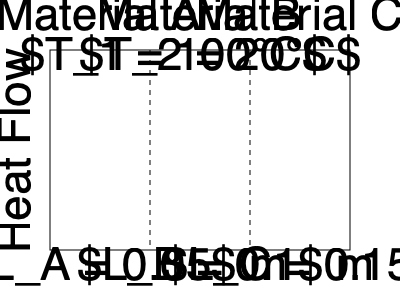A composite wall consists of three layers of materials A, B, and C with thermal conductivities $k_A = 0.8$ W/(m·K), $k_B = 0.5$ W/(m·K), and $k_C = 0.3$ W/(m·K), respectively. The thicknesses of the layers are $L_A = 0.05$ m, $L_B = 0.1$ m, and $L_C = 0.15$ m. If the temperature on the left side is $T_1 = 100°C$ and on the right side is $T_2 = 20°C$, calculate the heat flux through the wall in W/m². To solve this problem, we'll use the concept of thermal resistance in series and Fourier's law of heat conduction. Let's follow these steps:

1) Calculate the thermal resistance of each layer:
   $R_i = \frac{L_i}{k_i}$
   $R_A = \frac{0.05}{0.8} = 0.0625$ m²·K/W
   $R_B = \frac{0.1}{0.5} = 0.2$ m²·K/W
   $R_C = \frac{0.15}{0.3} = 0.5$ m²·K/W

2) Calculate the total thermal resistance:
   $R_{total} = R_A + R_B + R_C = 0.0625 + 0.2 + 0.5 = 0.7625$ m²·K/W

3) Use Fourier's law to calculate the heat flux:
   $q = \frac{\Delta T}{R_{total}} = \frac{T_1 - T_2}{R_{total}}$

4) Substitute the values:
   $q = \frac{100°C - 20°C}{0.7625 \text{ m²·K/W}} = \frac{80}{0.7625} = 104.92$ W/m²

Therefore, the heat flux through the composite wall is approximately 104.92 W/m².
Answer: 104.92 W/m² 